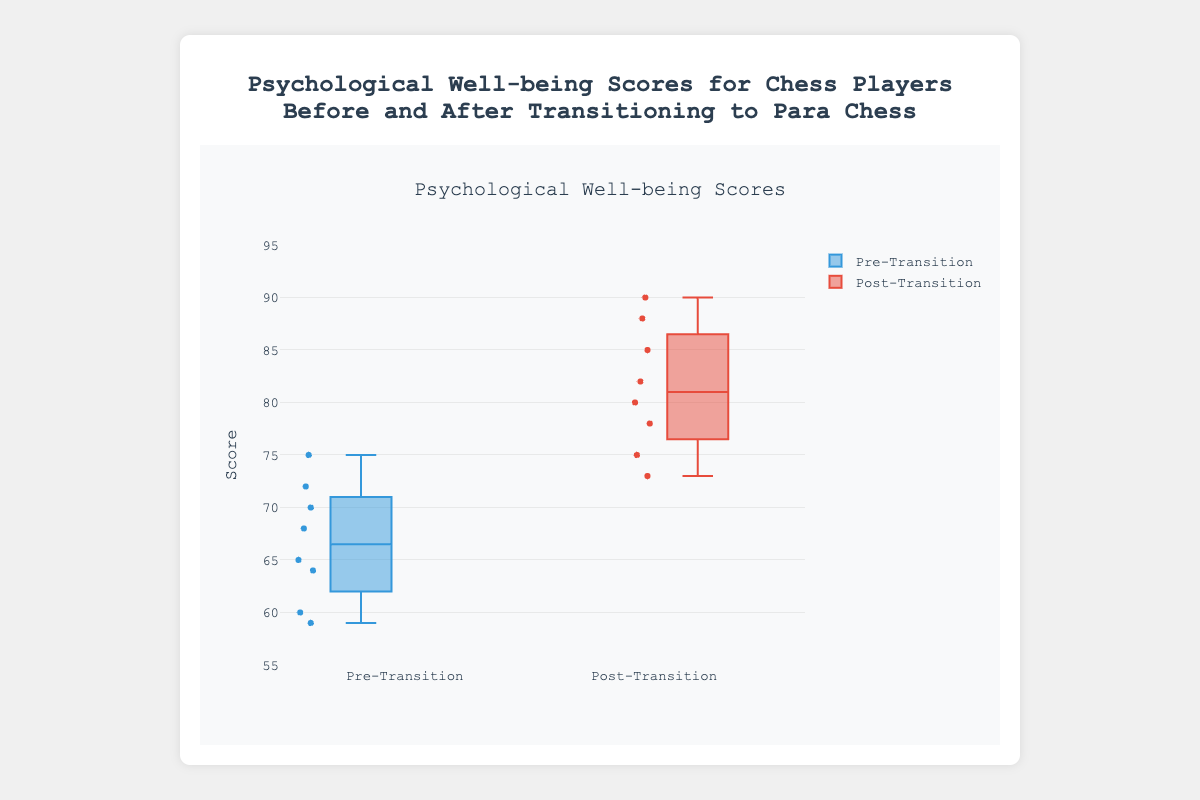What is the title of the figure? The title of the figure is typically found at the top of the chart, clearly indicating the subject of the data being presented.
Answer: Psychological Well-being Scores for Chess Players Before and After Transitioning to Para Chess What is the range of the y-axis in the figure? The y-axis range can usually be seen on the left side of the chart, specifying the minimum and maximum values the data points can take.
Answer: 55 to 95 What color represents the Pre-Transition scores in the box plot? The color of the Pre-Transition scores can be deduced from the labels and corresponding boxplot color in the plot.
Answer: Blue How many players are represented in both the Pre-Transition and Post-Transition scores? By counting the data points or referencing the provided data structure, the number of players can be determined.
Answer: 8 What is the median Pre-Transition score? The median score is the value that separates the higher half from the lower half of the data set. For Pre-Transition, locate the central line within the blue box.
Answer: 67 What is the interquartile range (IQR) for the Post-Transition scores? The IQR is the range between the first quartile (Q1) and the third quartile (Q3), representing the middle 50% of the data. Look for the box boundaries in the red plot.
Answer: 8 Is there an increase in the median score after transitioning to Para Chess? Compare the position of the median lines (the central lines within the boxes) of the Pre-Transition and Post-Transition plots.
Answer: Yes Which player's score increased the most after transitioning? By subtracting each player's Pre-Transition score from their Post-Transition score and comparing the differences, the player with the largest positive difference can be found.
Answer: Isabella Thomas Are there any visible outliers in the Pre-Transition or Post-Transition scores? Outliers are typically marked as individual points outside the whiskers of the boxplot. Scan for any such points in both plots.
Answer: No What is the difference between the lowest Post-Transition score and the highest Pre-Transition score? Identify the minimum value in the Post-Transition plot and the maximum value in the Pre-Transition plot, then calculate the difference.
Answer: 90 - 59 = 31 